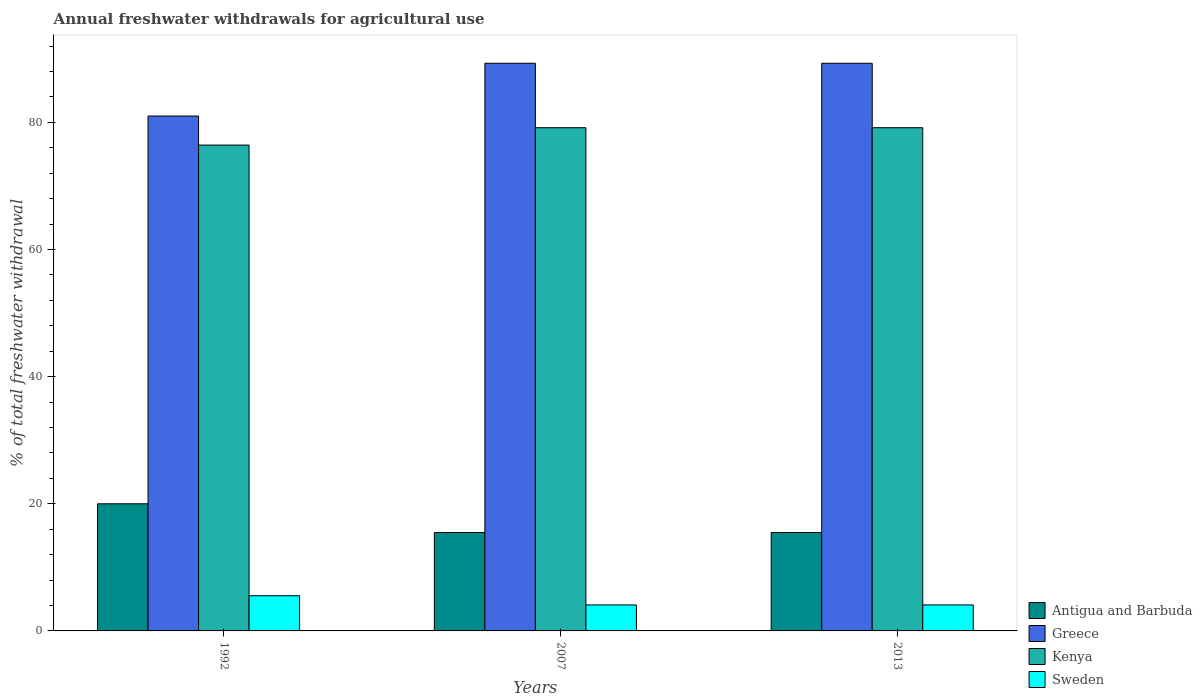How many different coloured bars are there?
Your response must be concise. 4. How many groups of bars are there?
Make the answer very short. 3. Are the number of bars on each tick of the X-axis equal?
Give a very brief answer. Yes. How many bars are there on the 2nd tick from the left?
Your answer should be compact. 4. What is the label of the 2nd group of bars from the left?
Your answer should be compact. 2007. In how many cases, is the number of bars for a given year not equal to the number of legend labels?
Your answer should be very brief. 0. What is the total annual withdrawals from freshwater in Greece in 2013?
Give a very brief answer. 89.3. Across all years, what is the minimum total annual withdrawals from freshwater in Antigua and Barbuda?
Provide a short and direct response. 15.48. In which year was the total annual withdrawals from freshwater in Antigua and Barbuda maximum?
Ensure brevity in your answer.  1992. What is the total total annual withdrawals from freshwater in Antigua and Barbuda in the graph?
Offer a terse response. 50.96. What is the difference between the total annual withdrawals from freshwater in Antigua and Barbuda in 2007 and that in 2013?
Keep it short and to the point. 0. What is the difference between the total annual withdrawals from freshwater in Greece in 1992 and the total annual withdrawals from freshwater in Sweden in 2013?
Offer a terse response. 76.91. What is the average total annual withdrawals from freshwater in Antigua and Barbuda per year?
Offer a very short reply. 16.99. In the year 1992, what is the difference between the total annual withdrawals from freshwater in Antigua and Barbuda and total annual withdrawals from freshwater in Greece?
Make the answer very short. -61. In how many years, is the total annual withdrawals from freshwater in Sweden greater than 76 %?
Give a very brief answer. 0. What is the ratio of the total annual withdrawals from freshwater in Sweden in 2007 to that in 2013?
Keep it short and to the point. 1. What is the difference between the highest and the lowest total annual withdrawals from freshwater in Sweden?
Your response must be concise. 1.45. In how many years, is the total annual withdrawals from freshwater in Kenya greater than the average total annual withdrawals from freshwater in Kenya taken over all years?
Offer a terse response. 2. Is it the case that in every year, the sum of the total annual withdrawals from freshwater in Greece and total annual withdrawals from freshwater in Kenya is greater than the sum of total annual withdrawals from freshwater in Antigua and Barbuda and total annual withdrawals from freshwater in Sweden?
Provide a short and direct response. No. What does the 2nd bar from the right in 2007 represents?
Your response must be concise. Kenya. How many bars are there?
Keep it short and to the point. 12. Are all the bars in the graph horizontal?
Provide a succinct answer. No. How many years are there in the graph?
Your response must be concise. 3. Where does the legend appear in the graph?
Offer a very short reply. Bottom right. What is the title of the graph?
Your answer should be compact. Annual freshwater withdrawals for agricultural use. What is the label or title of the X-axis?
Keep it short and to the point. Years. What is the label or title of the Y-axis?
Ensure brevity in your answer.  % of total freshwater withdrawal. What is the % of total freshwater withdrawal in Greece in 1992?
Offer a very short reply. 81. What is the % of total freshwater withdrawal in Kenya in 1992?
Ensure brevity in your answer.  76.43. What is the % of total freshwater withdrawal in Sweden in 1992?
Keep it short and to the point. 5.54. What is the % of total freshwater withdrawal in Antigua and Barbuda in 2007?
Provide a short and direct response. 15.48. What is the % of total freshwater withdrawal of Greece in 2007?
Keep it short and to the point. 89.3. What is the % of total freshwater withdrawal in Kenya in 2007?
Your response must be concise. 79.16. What is the % of total freshwater withdrawal in Sweden in 2007?
Your answer should be very brief. 4.09. What is the % of total freshwater withdrawal in Antigua and Barbuda in 2013?
Make the answer very short. 15.48. What is the % of total freshwater withdrawal in Greece in 2013?
Provide a succinct answer. 89.3. What is the % of total freshwater withdrawal in Kenya in 2013?
Your response must be concise. 79.16. What is the % of total freshwater withdrawal of Sweden in 2013?
Your answer should be very brief. 4.09. Across all years, what is the maximum % of total freshwater withdrawal in Greece?
Provide a short and direct response. 89.3. Across all years, what is the maximum % of total freshwater withdrawal in Kenya?
Offer a very short reply. 79.16. Across all years, what is the maximum % of total freshwater withdrawal in Sweden?
Ensure brevity in your answer.  5.54. Across all years, what is the minimum % of total freshwater withdrawal in Antigua and Barbuda?
Provide a succinct answer. 15.48. Across all years, what is the minimum % of total freshwater withdrawal in Greece?
Your answer should be very brief. 81. Across all years, what is the minimum % of total freshwater withdrawal of Kenya?
Offer a terse response. 76.43. Across all years, what is the minimum % of total freshwater withdrawal in Sweden?
Provide a succinct answer. 4.09. What is the total % of total freshwater withdrawal of Antigua and Barbuda in the graph?
Offer a terse response. 50.96. What is the total % of total freshwater withdrawal in Greece in the graph?
Keep it short and to the point. 259.6. What is the total % of total freshwater withdrawal in Kenya in the graph?
Offer a very short reply. 234.75. What is the total % of total freshwater withdrawal in Sweden in the graph?
Provide a succinct answer. 13.72. What is the difference between the % of total freshwater withdrawal of Antigua and Barbuda in 1992 and that in 2007?
Make the answer very short. 4.52. What is the difference between the % of total freshwater withdrawal in Greece in 1992 and that in 2007?
Make the answer very short. -8.3. What is the difference between the % of total freshwater withdrawal of Kenya in 1992 and that in 2007?
Offer a terse response. -2.73. What is the difference between the % of total freshwater withdrawal of Sweden in 1992 and that in 2007?
Make the answer very short. 1.45. What is the difference between the % of total freshwater withdrawal in Antigua and Barbuda in 1992 and that in 2013?
Your answer should be very brief. 4.52. What is the difference between the % of total freshwater withdrawal of Kenya in 1992 and that in 2013?
Give a very brief answer. -2.73. What is the difference between the % of total freshwater withdrawal in Sweden in 1992 and that in 2013?
Give a very brief answer. 1.45. What is the difference between the % of total freshwater withdrawal in Sweden in 2007 and that in 2013?
Your answer should be compact. 0. What is the difference between the % of total freshwater withdrawal in Antigua and Barbuda in 1992 and the % of total freshwater withdrawal in Greece in 2007?
Provide a short and direct response. -69.3. What is the difference between the % of total freshwater withdrawal in Antigua and Barbuda in 1992 and the % of total freshwater withdrawal in Kenya in 2007?
Ensure brevity in your answer.  -59.16. What is the difference between the % of total freshwater withdrawal in Antigua and Barbuda in 1992 and the % of total freshwater withdrawal in Sweden in 2007?
Offer a terse response. 15.91. What is the difference between the % of total freshwater withdrawal in Greece in 1992 and the % of total freshwater withdrawal in Kenya in 2007?
Ensure brevity in your answer.  1.84. What is the difference between the % of total freshwater withdrawal in Greece in 1992 and the % of total freshwater withdrawal in Sweden in 2007?
Make the answer very short. 76.91. What is the difference between the % of total freshwater withdrawal of Kenya in 1992 and the % of total freshwater withdrawal of Sweden in 2007?
Keep it short and to the point. 72.34. What is the difference between the % of total freshwater withdrawal in Antigua and Barbuda in 1992 and the % of total freshwater withdrawal in Greece in 2013?
Keep it short and to the point. -69.3. What is the difference between the % of total freshwater withdrawal in Antigua and Barbuda in 1992 and the % of total freshwater withdrawal in Kenya in 2013?
Your answer should be very brief. -59.16. What is the difference between the % of total freshwater withdrawal of Antigua and Barbuda in 1992 and the % of total freshwater withdrawal of Sweden in 2013?
Provide a short and direct response. 15.91. What is the difference between the % of total freshwater withdrawal of Greece in 1992 and the % of total freshwater withdrawal of Kenya in 2013?
Make the answer very short. 1.84. What is the difference between the % of total freshwater withdrawal in Greece in 1992 and the % of total freshwater withdrawal in Sweden in 2013?
Your response must be concise. 76.91. What is the difference between the % of total freshwater withdrawal of Kenya in 1992 and the % of total freshwater withdrawal of Sweden in 2013?
Your answer should be very brief. 72.34. What is the difference between the % of total freshwater withdrawal of Antigua and Barbuda in 2007 and the % of total freshwater withdrawal of Greece in 2013?
Your answer should be compact. -73.82. What is the difference between the % of total freshwater withdrawal in Antigua and Barbuda in 2007 and the % of total freshwater withdrawal in Kenya in 2013?
Provide a short and direct response. -63.68. What is the difference between the % of total freshwater withdrawal of Antigua and Barbuda in 2007 and the % of total freshwater withdrawal of Sweden in 2013?
Ensure brevity in your answer.  11.39. What is the difference between the % of total freshwater withdrawal in Greece in 2007 and the % of total freshwater withdrawal in Kenya in 2013?
Your answer should be very brief. 10.14. What is the difference between the % of total freshwater withdrawal in Greece in 2007 and the % of total freshwater withdrawal in Sweden in 2013?
Offer a very short reply. 85.21. What is the difference between the % of total freshwater withdrawal in Kenya in 2007 and the % of total freshwater withdrawal in Sweden in 2013?
Keep it short and to the point. 75.07. What is the average % of total freshwater withdrawal in Antigua and Barbuda per year?
Provide a succinct answer. 16.99. What is the average % of total freshwater withdrawal of Greece per year?
Your answer should be compact. 86.53. What is the average % of total freshwater withdrawal of Kenya per year?
Keep it short and to the point. 78.25. What is the average % of total freshwater withdrawal of Sweden per year?
Provide a short and direct response. 4.57. In the year 1992, what is the difference between the % of total freshwater withdrawal of Antigua and Barbuda and % of total freshwater withdrawal of Greece?
Your answer should be very brief. -61. In the year 1992, what is the difference between the % of total freshwater withdrawal in Antigua and Barbuda and % of total freshwater withdrawal in Kenya?
Provide a short and direct response. -56.43. In the year 1992, what is the difference between the % of total freshwater withdrawal of Antigua and Barbuda and % of total freshwater withdrawal of Sweden?
Give a very brief answer. 14.46. In the year 1992, what is the difference between the % of total freshwater withdrawal in Greece and % of total freshwater withdrawal in Kenya?
Provide a short and direct response. 4.57. In the year 1992, what is the difference between the % of total freshwater withdrawal in Greece and % of total freshwater withdrawal in Sweden?
Your response must be concise. 75.46. In the year 1992, what is the difference between the % of total freshwater withdrawal in Kenya and % of total freshwater withdrawal in Sweden?
Your response must be concise. 70.89. In the year 2007, what is the difference between the % of total freshwater withdrawal in Antigua and Barbuda and % of total freshwater withdrawal in Greece?
Offer a very short reply. -73.82. In the year 2007, what is the difference between the % of total freshwater withdrawal in Antigua and Barbuda and % of total freshwater withdrawal in Kenya?
Make the answer very short. -63.68. In the year 2007, what is the difference between the % of total freshwater withdrawal in Antigua and Barbuda and % of total freshwater withdrawal in Sweden?
Offer a terse response. 11.39. In the year 2007, what is the difference between the % of total freshwater withdrawal in Greece and % of total freshwater withdrawal in Kenya?
Give a very brief answer. 10.14. In the year 2007, what is the difference between the % of total freshwater withdrawal in Greece and % of total freshwater withdrawal in Sweden?
Provide a short and direct response. 85.21. In the year 2007, what is the difference between the % of total freshwater withdrawal in Kenya and % of total freshwater withdrawal in Sweden?
Offer a very short reply. 75.07. In the year 2013, what is the difference between the % of total freshwater withdrawal in Antigua and Barbuda and % of total freshwater withdrawal in Greece?
Give a very brief answer. -73.82. In the year 2013, what is the difference between the % of total freshwater withdrawal of Antigua and Barbuda and % of total freshwater withdrawal of Kenya?
Your answer should be very brief. -63.68. In the year 2013, what is the difference between the % of total freshwater withdrawal of Antigua and Barbuda and % of total freshwater withdrawal of Sweden?
Your answer should be compact. 11.39. In the year 2013, what is the difference between the % of total freshwater withdrawal of Greece and % of total freshwater withdrawal of Kenya?
Provide a succinct answer. 10.14. In the year 2013, what is the difference between the % of total freshwater withdrawal in Greece and % of total freshwater withdrawal in Sweden?
Keep it short and to the point. 85.21. In the year 2013, what is the difference between the % of total freshwater withdrawal in Kenya and % of total freshwater withdrawal in Sweden?
Give a very brief answer. 75.07. What is the ratio of the % of total freshwater withdrawal of Antigua and Barbuda in 1992 to that in 2007?
Make the answer very short. 1.29. What is the ratio of the % of total freshwater withdrawal of Greece in 1992 to that in 2007?
Provide a succinct answer. 0.91. What is the ratio of the % of total freshwater withdrawal of Kenya in 1992 to that in 2007?
Ensure brevity in your answer.  0.97. What is the ratio of the % of total freshwater withdrawal in Sweden in 1992 to that in 2007?
Your response must be concise. 1.35. What is the ratio of the % of total freshwater withdrawal in Antigua and Barbuda in 1992 to that in 2013?
Make the answer very short. 1.29. What is the ratio of the % of total freshwater withdrawal in Greece in 1992 to that in 2013?
Make the answer very short. 0.91. What is the ratio of the % of total freshwater withdrawal of Kenya in 1992 to that in 2013?
Provide a short and direct response. 0.97. What is the ratio of the % of total freshwater withdrawal of Sweden in 1992 to that in 2013?
Provide a succinct answer. 1.35. What is the difference between the highest and the second highest % of total freshwater withdrawal of Antigua and Barbuda?
Your answer should be very brief. 4.52. What is the difference between the highest and the second highest % of total freshwater withdrawal in Greece?
Offer a terse response. 0. What is the difference between the highest and the second highest % of total freshwater withdrawal of Kenya?
Give a very brief answer. 0. What is the difference between the highest and the second highest % of total freshwater withdrawal in Sweden?
Ensure brevity in your answer.  1.45. What is the difference between the highest and the lowest % of total freshwater withdrawal of Antigua and Barbuda?
Your response must be concise. 4.52. What is the difference between the highest and the lowest % of total freshwater withdrawal of Kenya?
Provide a succinct answer. 2.73. What is the difference between the highest and the lowest % of total freshwater withdrawal of Sweden?
Give a very brief answer. 1.45. 